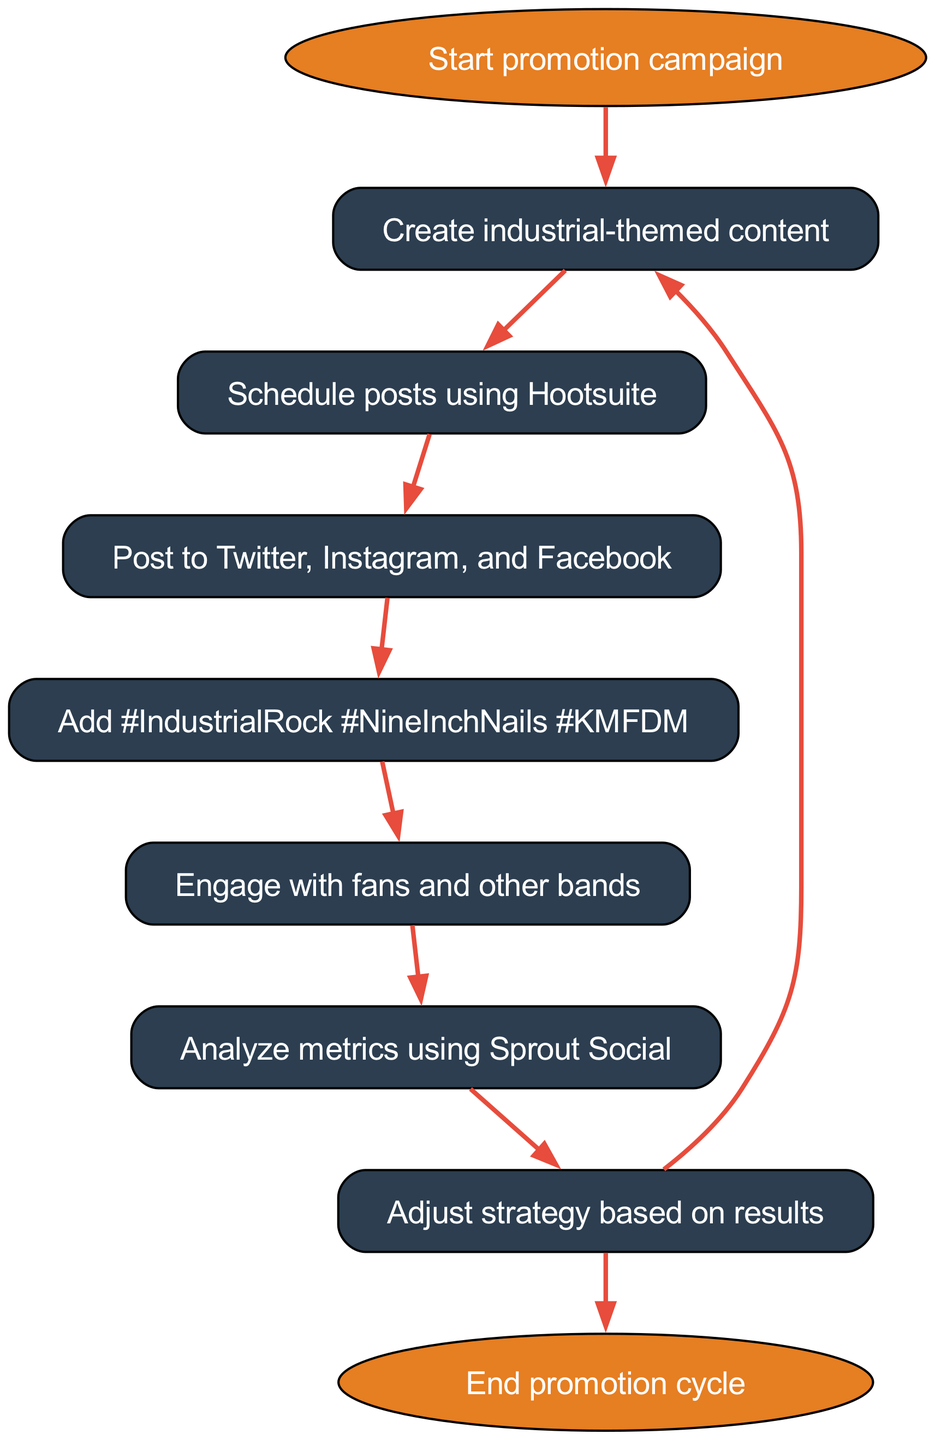What is the starting point of the workflow? The starting point of the workflow is represented by the node labeled "Start promotion campaign". This node is the first element in the flowchart, clearly indicating where the process begins.
Answer: Start promotion campaign How many edges are present in the diagram? To find the number of edges, we look at the connections between nodes. In this case, there are a total of 8 edges listed in the diagram that connect the nodes in the workflow.
Answer: 8 What node comes after "Schedule posts using Hootsuite"? Following the node "Schedule posts using Hootsuite", the next node in the flow is labeled "Post to Twitter, Instagram, and Facebook". This direct connection indicates the sequential nature of the tasks.
Answer: Post to Twitter, Instagram, and Facebook What hashtags are included in the promotion? The node labeled "Add #IndustrialRock #NineInchNails #KMFDM" specifically lists the hashtags, making it clear that these are the key tags used for promotion in the workflow.
Answer: #IndustrialRock #NineInchNails #KMFDM What happens after the "Adjust strategy based on results" node? After the "Adjust strategy based on results" node, the flowchart shows two possible paths: one leads back to "Create industrial-themed content" and the other leads to "End promotion cycle". This bifurcation indicates a decision point based on the results of analysis.
Answer: Create industrial-themed content, End promotion cycle Which node indicates the analysis of metrics? The node representing the analysis of metrics is labeled "Analyze metrics using Sprout Social". This node specifically mentions the tool to be used for analyzing social media performance, thus identifying where the analysis occurs in the workflow.
Answer: Analyze metrics using Sprout Social What is the last step of the workflow? The last step of the workflow is depicted by the "End promotion cycle" node. This node signifies the conclusion of the promotional activities, marking the final point in the flowchart.
Answer: End promotion cycle How is fan engagement incorporated into the workflow? Fan engagement is represented by the node "Engage with fans and other bands". This indicates that outreach and interaction with the audience and other musical entities are a crucial part of the promotional process, occurring after posting content.
Answer: Engage with fans and other bands 